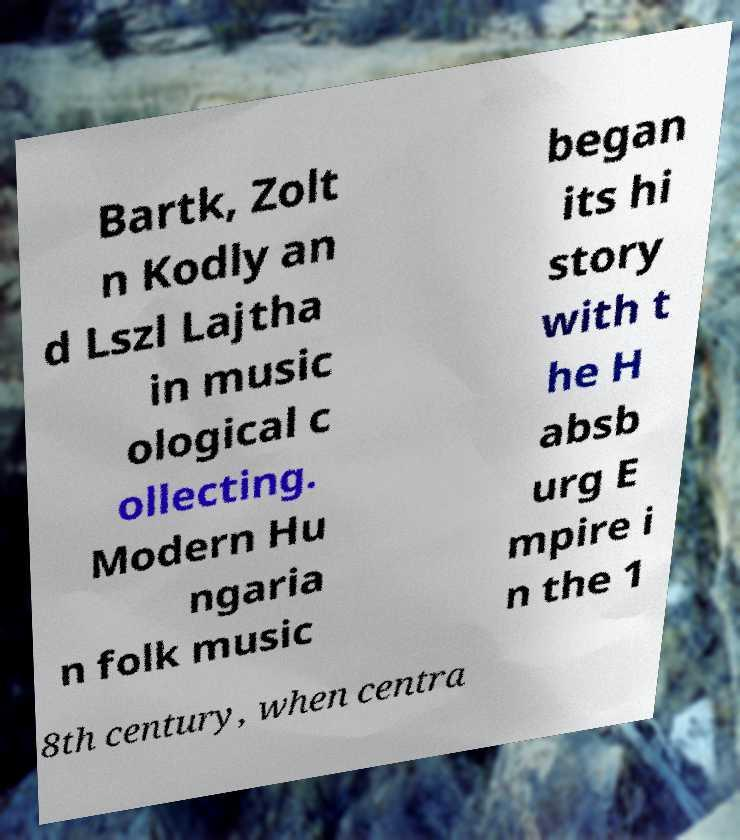Can you read and provide the text displayed in the image?This photo seems to have some interesting text. Can you extract and type it out for me? Bartk, Zolt n Kodly an d Lszl Lajtha in music ological c ollecting. Modern Hu ngaria n folk music began its hi story with t he H absb urg E mpire i n the 1 8th century, when centra 